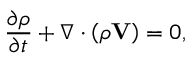Convert formula to latex. <formula><loc_0><loc_0><loc_500><loc_500>\frac { \partial \rho } { \partial t } + \nabla \cdot \left ( \rho V \right ) = 0 ,</formula> 